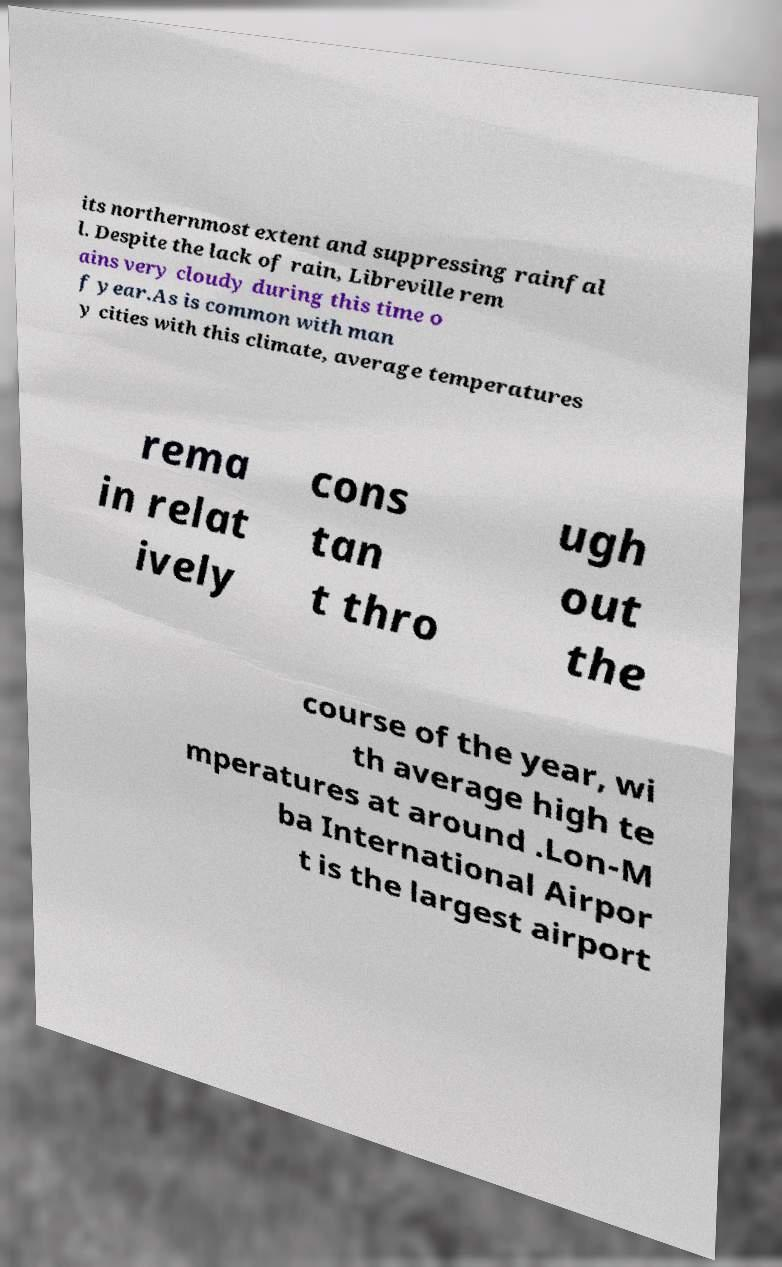For documentation purposes, I need the text within this image transcribed. Could you provide that? its northernmost extent and suppressing rainfal l. Despite the lack of rain, Libreville rem ains very cloudy during this time o f year.As is common with man y cities with this climate, average temperatures rema in relat ively cons tan t thro ugh out the course of the year, wi th average high te mperatures at around .Lon-M ba International Airpor t is the largest airport 